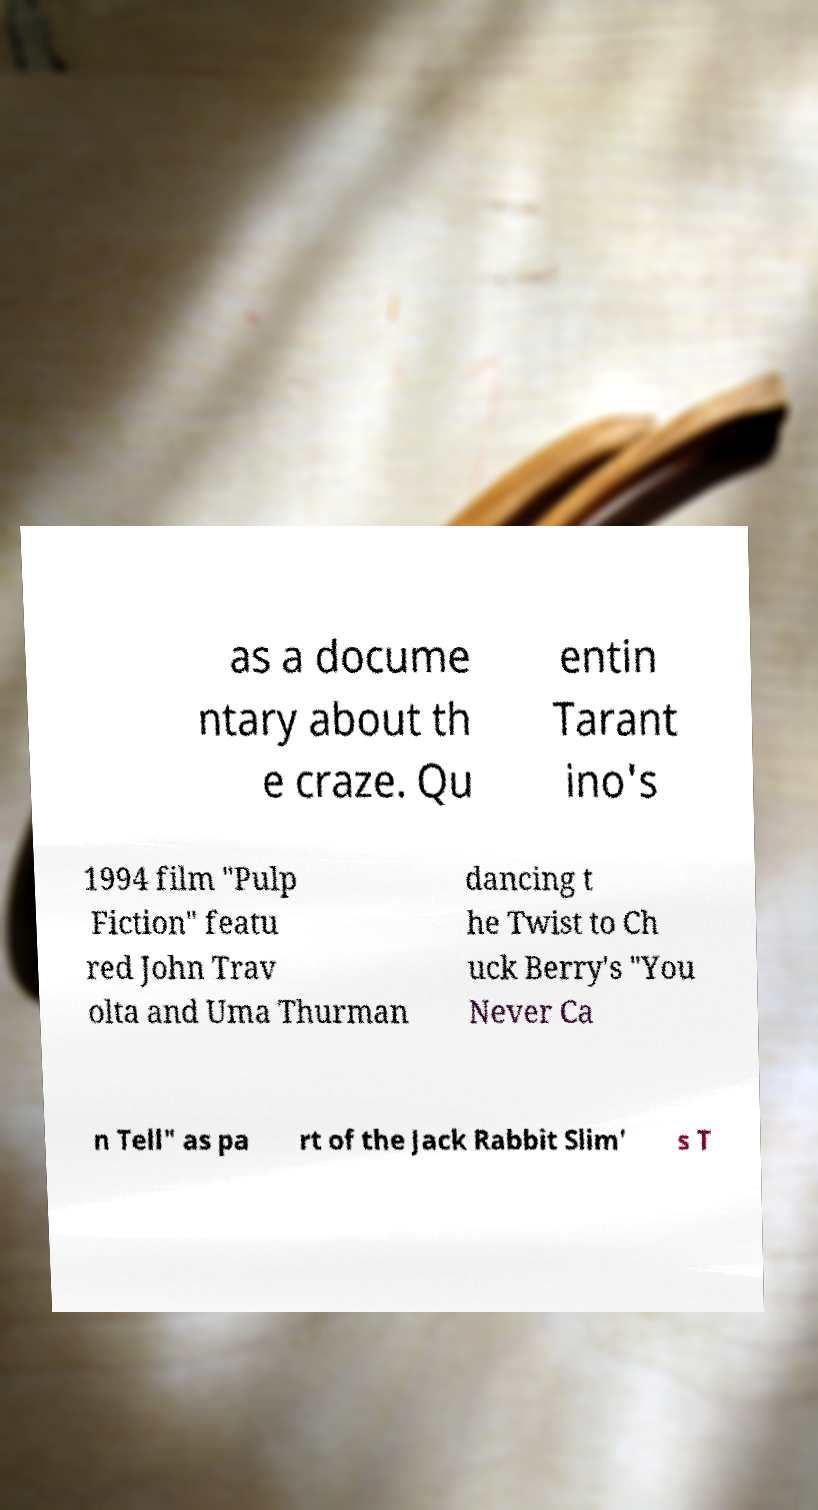I need the written content from this picture converted into text. Can you do that? as a docume ntary about th e craze. Qu entin Tarant ino's 1994 film "Pulp Fiction" featu red John Trav olta and Uma Thurman dancing t he Twist to Ch uck Berry's "You Never Ca n Tell" as pa rt of the Jack Rabbit Slim' s T 